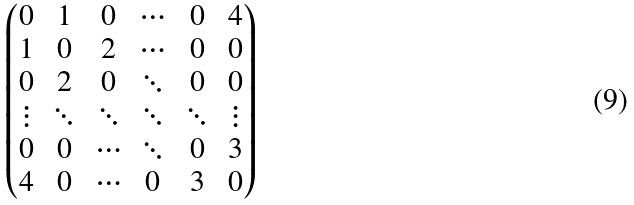Convert formula to latex. <formula><loc_0><loc_0><loc_500><loc_500>\begin{pmatrix} 0 & 1 & 0 & \cdots & 0 & 4 \\ 1 & 0 & 2 & \cdots & 0 & 0 \\ 0 & 2 & 0 & \ddots & 0 & 0 \\ \vdots & \ddots & \ddots & \ddots & \ddots & \vdots \\ 0 & 0 & \cdots & \ddots & 0 & 3 \\ 4 & 0 & \cdots & 0 & 3 & 0 \end{pmatrix}</formula> 